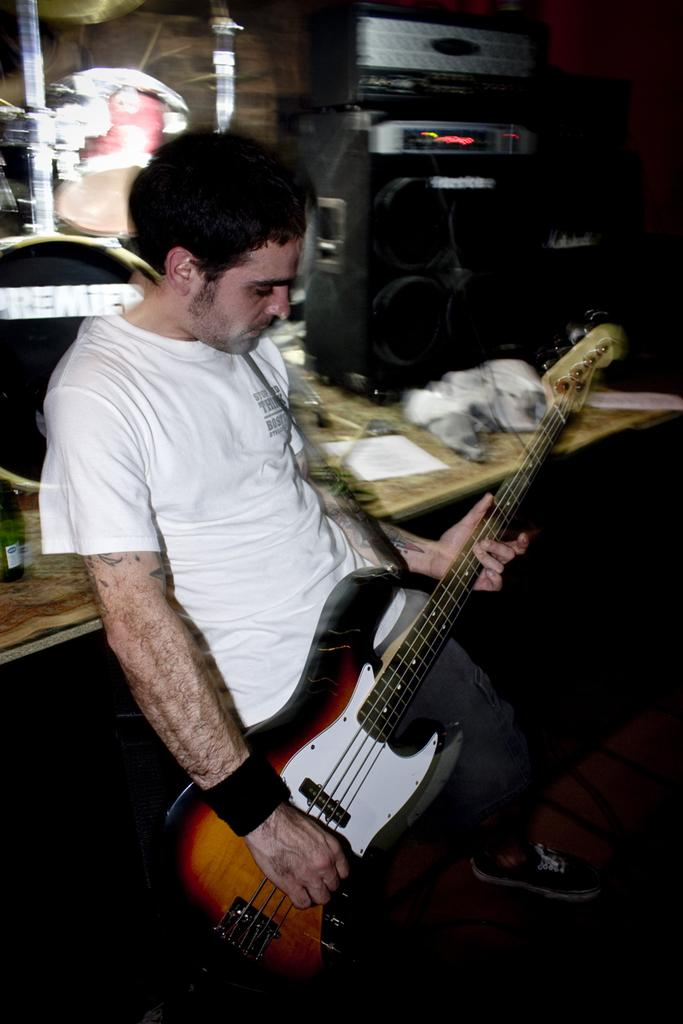Who is present in the image? There is a man in the image. What is the man doing in the image? The man is standing in the image. What object is the man holding in the image? The man is holding a guitar in the image. What can be seen in the background of the image? There is a speaker and a drum set in the background of the image. What type of fiction is the man reading in the image? There is no book or any form of fiction present in the image. 